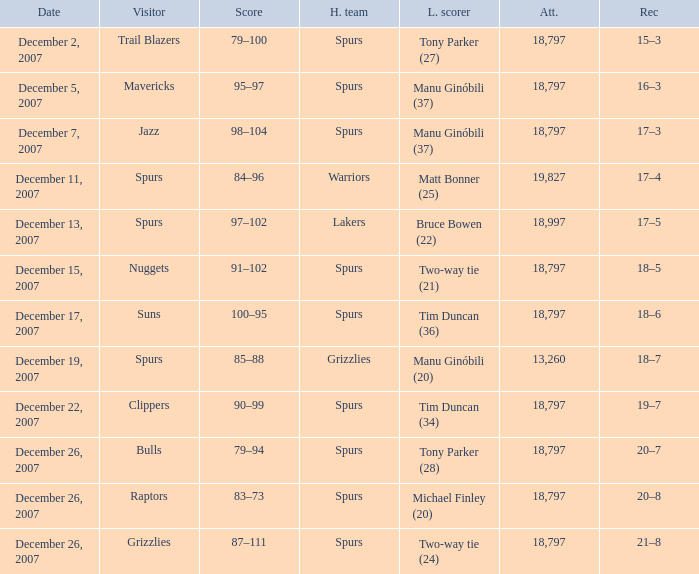What is the record of the game on December 5, 2007? 16–3. 